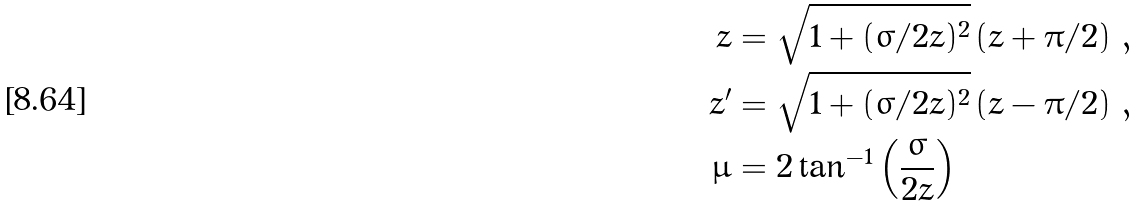Convert formula to latex. <formula><loc_0><loc_0><loc_500><loc_500>z & = \sqrt { 1 + ( \sigma / 2 \bar { z } ) ^ { 2 } } \left ( \bar { z } + \pi / 2 \right ) \, , \\ z ^ { \prime } & = \sqrt { 1 + ( \sigma / 2 \bar { z } ) ^ { 2 } } \left ( \bar { z } - \pi / 2 \right ) \, , \\ \mu & = 2 \tan ^ { - 1 } \left ( \frac { \sigma } { 2 \bar { z } } \right )</formula> 